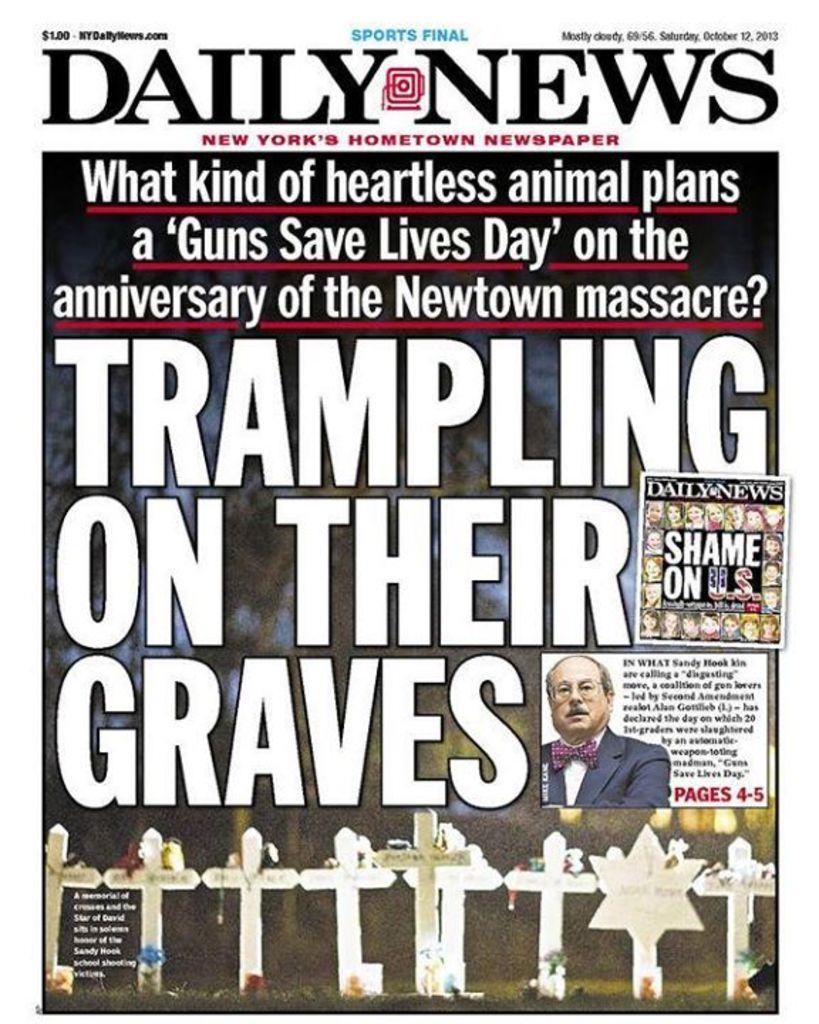Could you give a brief overview of what you see in this image? In this image I can see few religious cross symbols and I can also see the person and I can see something written on the image and the background is in blue and green color. 